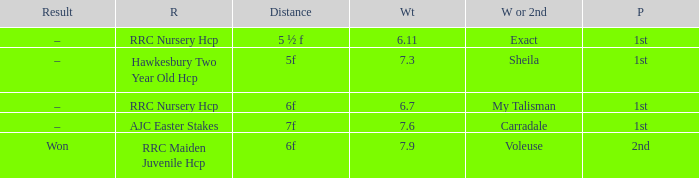What was the race when the winner of 2nd was Voleuse? RRC Maiden Juvenile Hcp. 